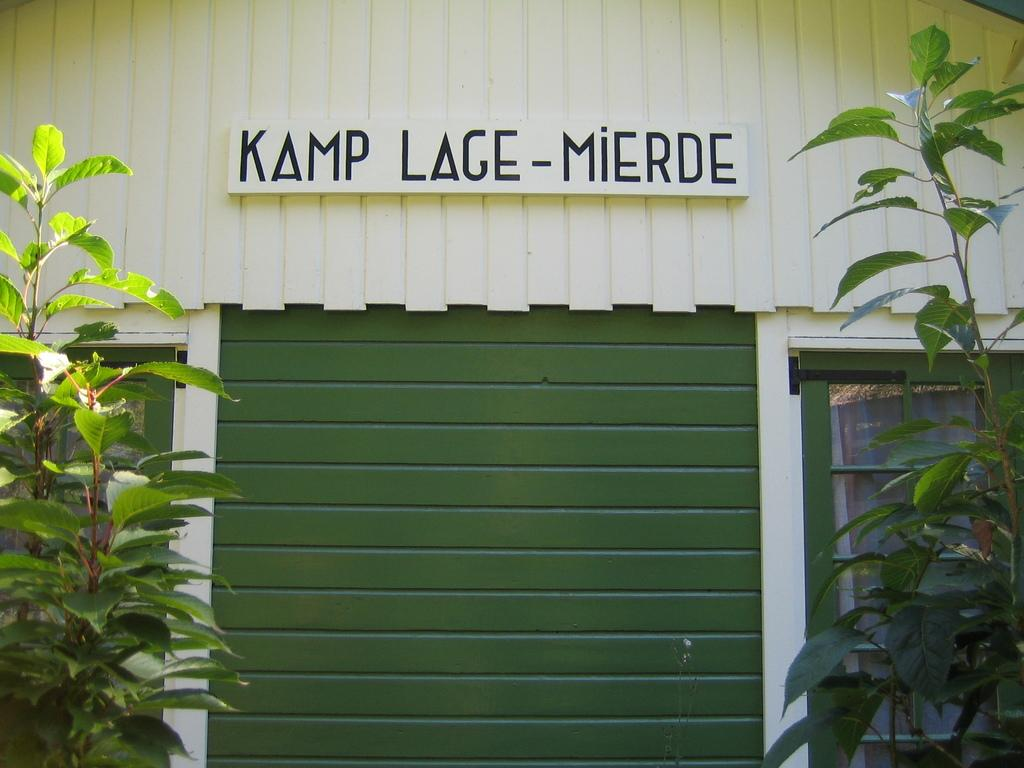What is the main structure in the image? There is a compartment in the image. What feature does the compartment have on its sides? The compartment has two windows on either side. What is placed in front of the compartment? There are two plants in front of the compartment. What type of apple is being used in the battle depicted in the image? There is no apple or battle present in the image; it features a compartment with two windows and two plants in front of it. 